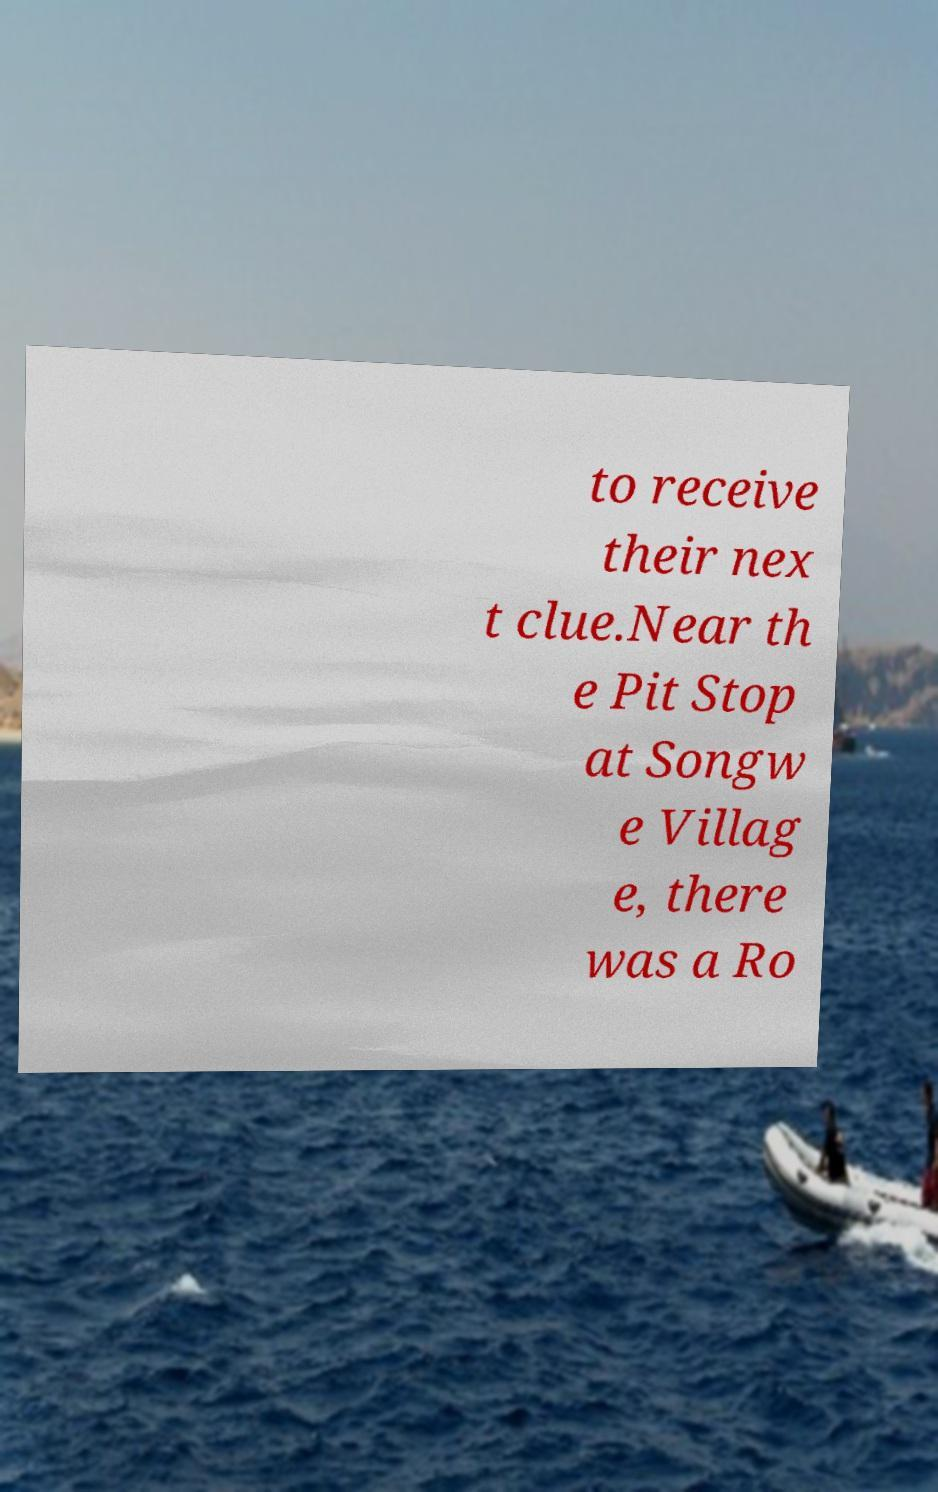Could you extract and type out the text from this image? to receive their nex t clue.Near th e Pit Stop at Songw e Villag e, there was a Ro 